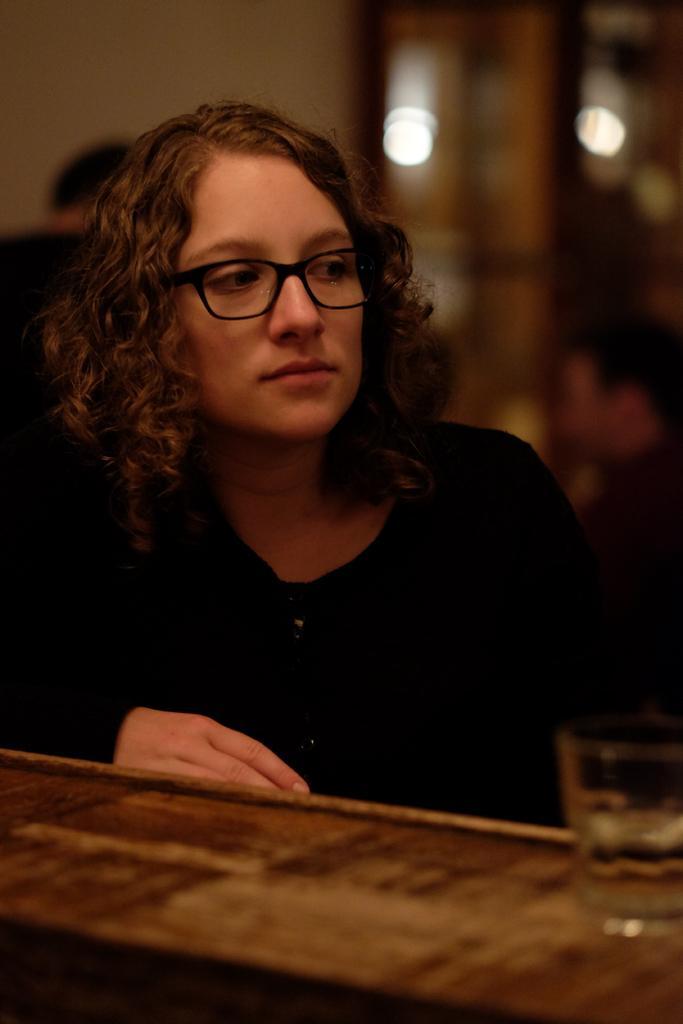Can you describe this image briefly? There is a woman looking at right side and wore spectacle,in front of this woman we can see glass on the table. In the background it is blur. 